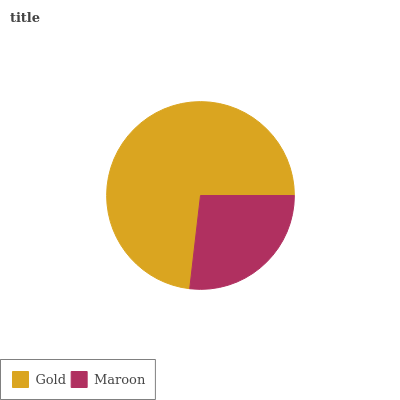Is Maroon the minimum?
Answer yes or no. Yes. Is Gold the maximum?
Answer yes or no. Yes. Is Maroon the maximum?
Answer yes or no. No. Is Gold greater than Maroon?
Answer yes or no. Yes. Is Maroon less than Gold?
Answer yes or no. Yes. Is Maroon greater than Gold?
Answer yes or no. No. Is Gold less than Maroon?
Answer yes or no. No. Is Gold the high median?
Answer yes or no. Yes. Is Maroon the low median?
Answer yes or no. Yes. Is Maroon the high median?
Answer yes or no. No. Is Gold the low median?
Answer yes or no. No. 